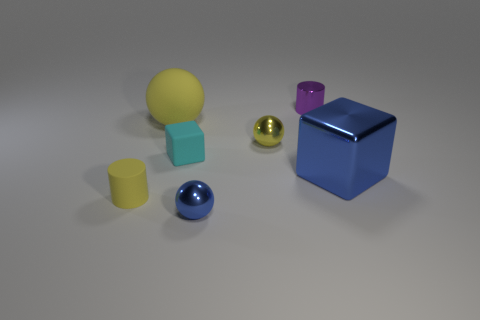Add 2 blue blocks. How many objects exist? 9 Subtract all blue metal spheres. How many spheres are left? 2 Subtract all cyan blocks. How many blocks are left? 1 Subtract all balls. How many objects are left? 4 Add 1 small cyan things. How many small cyan things are left? 2 Add 7 blue spheres. How many blue spheres exist? 8 Subtract 1 cyan cubes. How many objects are left? 6 Subtract 1 cubes. How many cubes are left? 1 Subtract all brown cubes. Subtract all red spheres. How many cubes are left? 2 Subtract all gray balls. How many cyan blocks are left? 1 